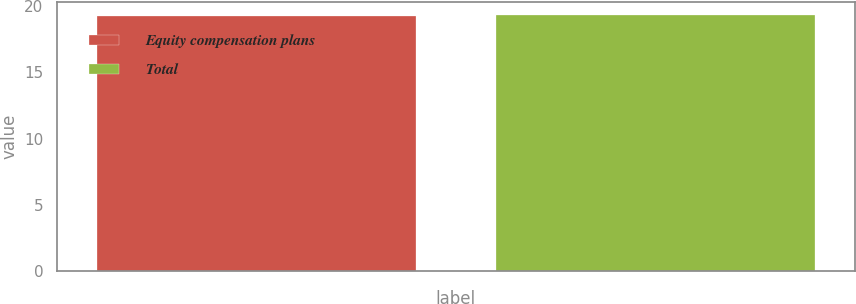Convert chart to OTSL. <chart><loc_0><loc_0><loc_500><loc_500><bar_chart><fcel>Equity compensation plans<fcel>Total<nl><fcel>19.21<fcel>19.31<nl></chart> 